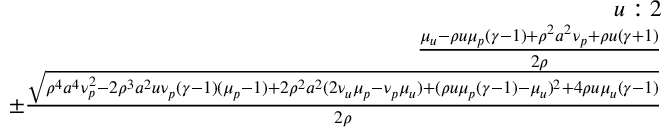<formula> <loc_0><loc_0><loc_500><loc_500>\begin{array} { r } { u \colon 2 } \\ { \frac { \mu _ { u } - \rho u \mu _ { p } ( \gamma - 1 ) + \rho ^ { 2 } a ^ { 2 } \nu _ { p } + \rho u ( \gamma + 1 ) } { 2 \rho } } \\ { \pm \frac { \sqrt { \rho ^ { 4 } a ^ { 4 } \nu _ { p } ^ { 2 } - 2 \rho ^ { 3 } a ^ { 2 } u \nu _ { p } ( \gamma - 1 ) ( \mu _ { p } - 1 ) + 2 \rho ^ { 2 } a ^ { 2 } ( 2 \nu _ { u } \mu _ { p } - \nu _ { p } \mu _ { u } ) + ( \rho u \mu _ { p } ( \gamma - 1 ) - \mu _ { u } ) ^ { 2 } + 4 \rho u \mu _ { u } ( \gamma - 1 ) } } { 2 \rho } } \end{array}</formula> 